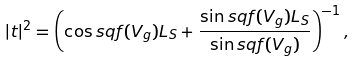<formula> <loc_0><loc_0><loc_500><loc_500>| t | ^ { 2 } = \left ( \cos s q { f ( V _ { g } ) L _ { S } } + \frac { \sin s q { f ( V _ { g } ) L _ { S } } } { \sin s q { f ( V _ { g } ) } } \right ) ^ { - 1 } ,</formula> 